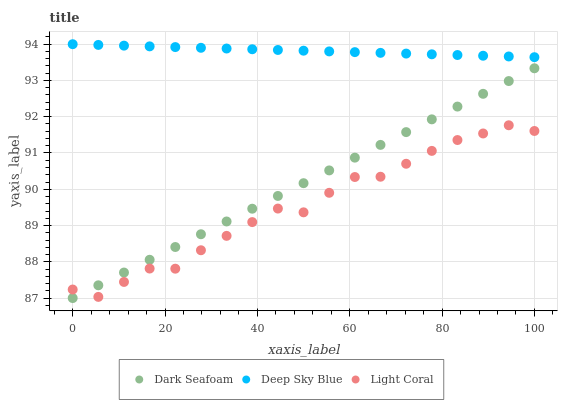Does Light Coral have the minimum area under the curve?
Answer yes or no. Yes. Does Deep Sky Blue have the maximum area under the curve?
Answer yes or no. Yes. Does Dark Seafoam have the minimum area under the curve?
Answer yes or no. No. Does Dark Seafoam have the maximum area under the curve?
Answer yes or no. No. Is Dark Seafoam the smoothest?
Answer yes or no. Yes. Is Light Coral the roughest?
Answer yes or no. Yes. Is Deep Sky Blue the smoothest?
Answer yes or no. No. Is Deep Sky Blue the roughest?
Answer yes or no. No. Does Dark Seafoam have the lowest value?
Answer yes or no. Yes. Does Deep Sky Blue have the lowest value?
Answer yes or no. No. Does Deep Sky Blue have the highest value?
Answer yes or no. Yes. Does Dark Seafoam have the highest value?
Answer yes or no. No. Is Light Coral less than Deep Sky Blue?
Answer yes or no. Yes. Is Deep Sky Blue greater than Dark Seafoam?
Answer yes or no. Yes. Does Light Coral intersect Dark Seafoam?
Answer yes or no. Yes. Is Light Coral less than Dark Seafoam?
Answer yes or no. No. Is Light Coral greater than Dark Seafoam?
Answer yes or no. No. Does Light Coral intersect Deep Sky Blue?
Answer yes or no. No. 